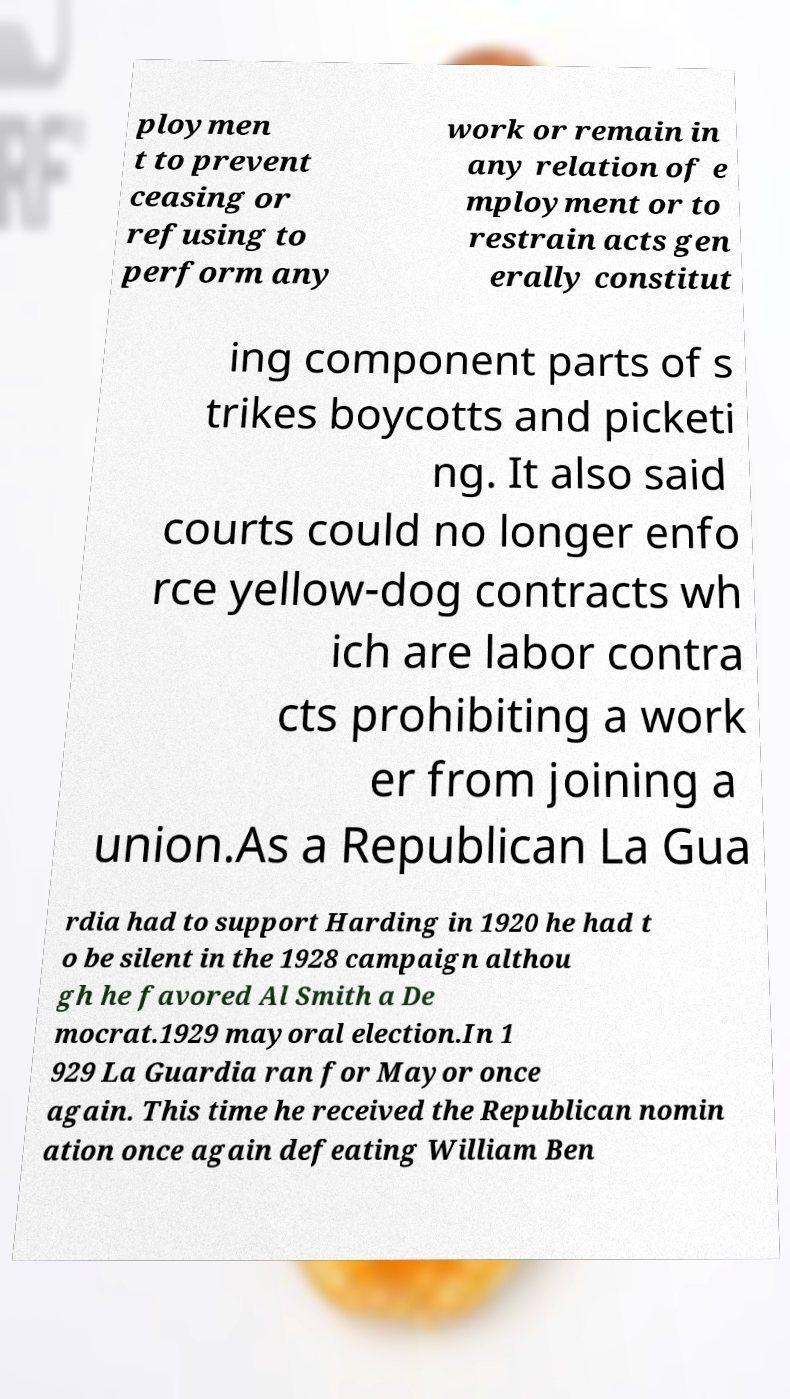Please identify and transcribe the text found in this image. ploymen t to prevent ceasing or refusing to perform any work or remain in any relation of e mployment or to restrain acts gen erally constitut ing component parts of s trikes boycotts and picketi ng. It also said courts could no longer enfo rce yellow-dog contracts wh ich are labor contra cts prohibiting a work er from joining a union.As a Republican La Gua rdia had to support Harding in 1920 he had t o be silent in the 1928 campaign althou gh he favored Al Smith a De mocrat.1929 mayoral election.In 1 929 La Guardia ran for Mayor once again. This time he received the Republican nomin ation once again defeating William Ben 